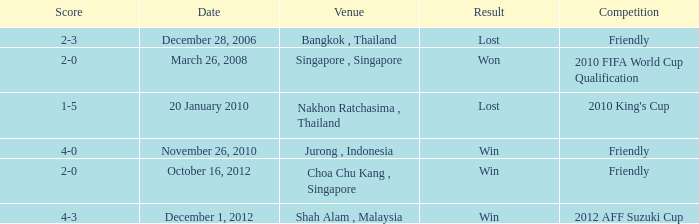Name the venue for friendly competition october 16, 2012 Choa Chu Kang , Singapore. 